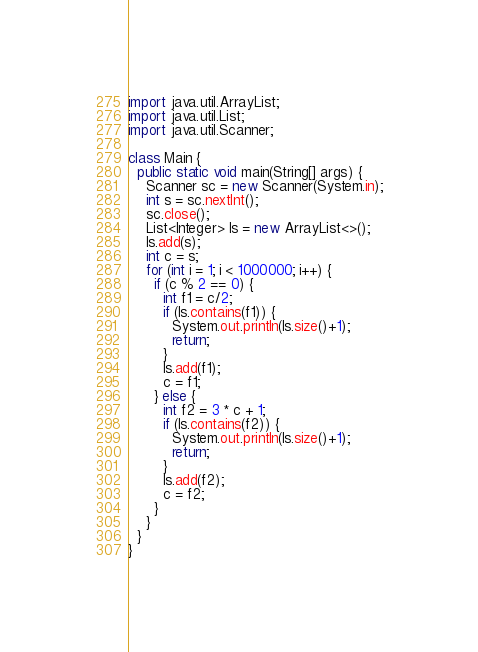Convert code to text. <code><loc_0><loc_0><loc_500><loc_500><_Java_>import java.util.ArrayList;
import java.util.List;
import java.util.Scanner;

class Main {
  public static void main(String[] args) {
    Scanner sc = new Scanner(System.in);
    int s = sc.nextInt();
    sc.close();
    List<Integer> ls = new ArrayList<>();
    ls.add(s);
    int c = s;
    for (int i = 1; i < 1000000; i++) {
      if (c % 2 == 0) {
        int f1 = c/2;
        if (ls.contains(f1)) {
          System.out.println(ls.size()+1);
          return;
        }
        ls.add(f1);
        c = f1;
      } else {
        int f2 = 3 * c + 1;
        if (ls.contains(f2)) {
          System.out.println(ls.size()+1);
          return;
        }
        ls.add(f2);
        c = f2;
      }
    }
  }
}
</code> 